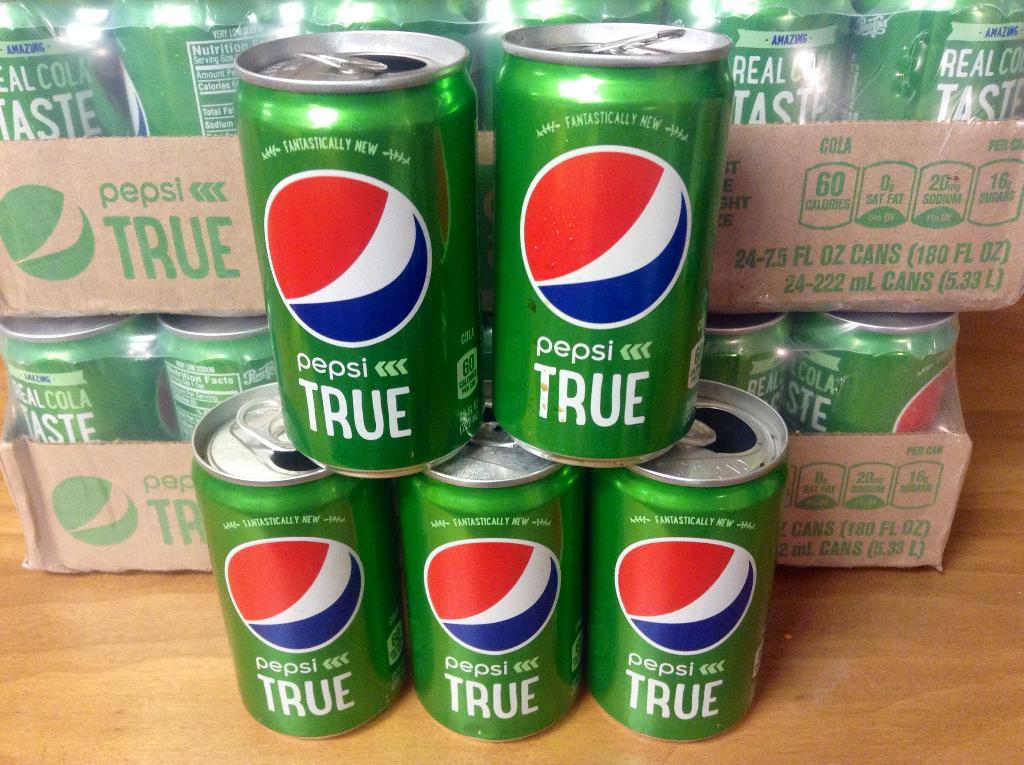What brand is this?
Offer a terse response. Pepsi. 